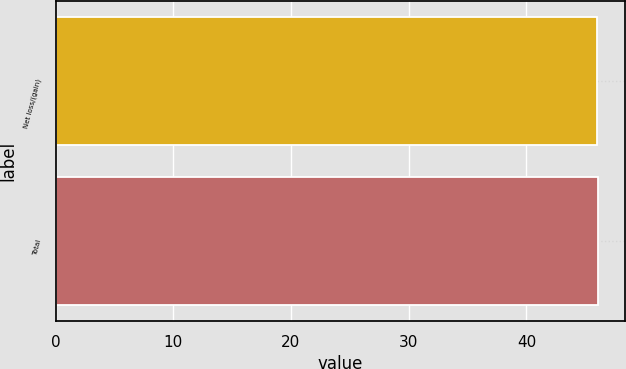Convert chart to OTSL. <chart><loc_0><loc_0><loc_500><loc_500><bar_chart><fcel>Net loss/(gain)<fcel>Total<nl><fcel>46<fcel>46.1<nl></chart> 